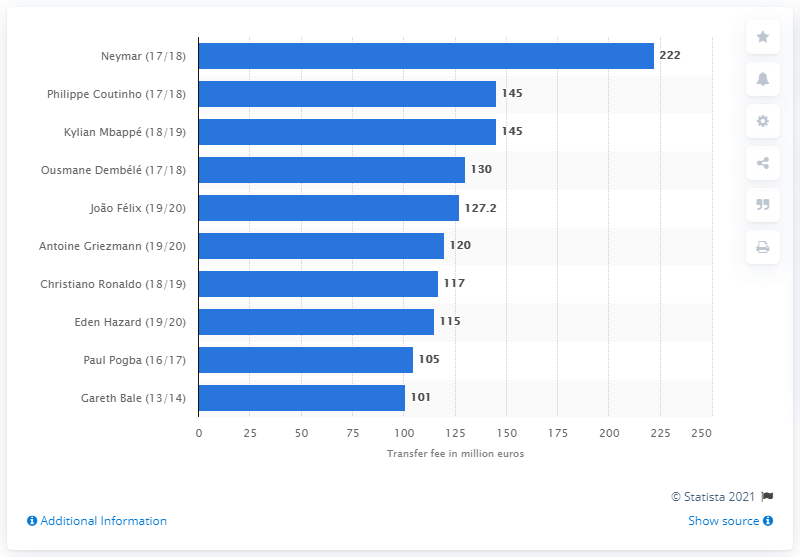Mention a couple of crucial points in this snapshot. Neymar's transfer from Barcelona to Paris Saint-Germain was valued at 222 million euros. 